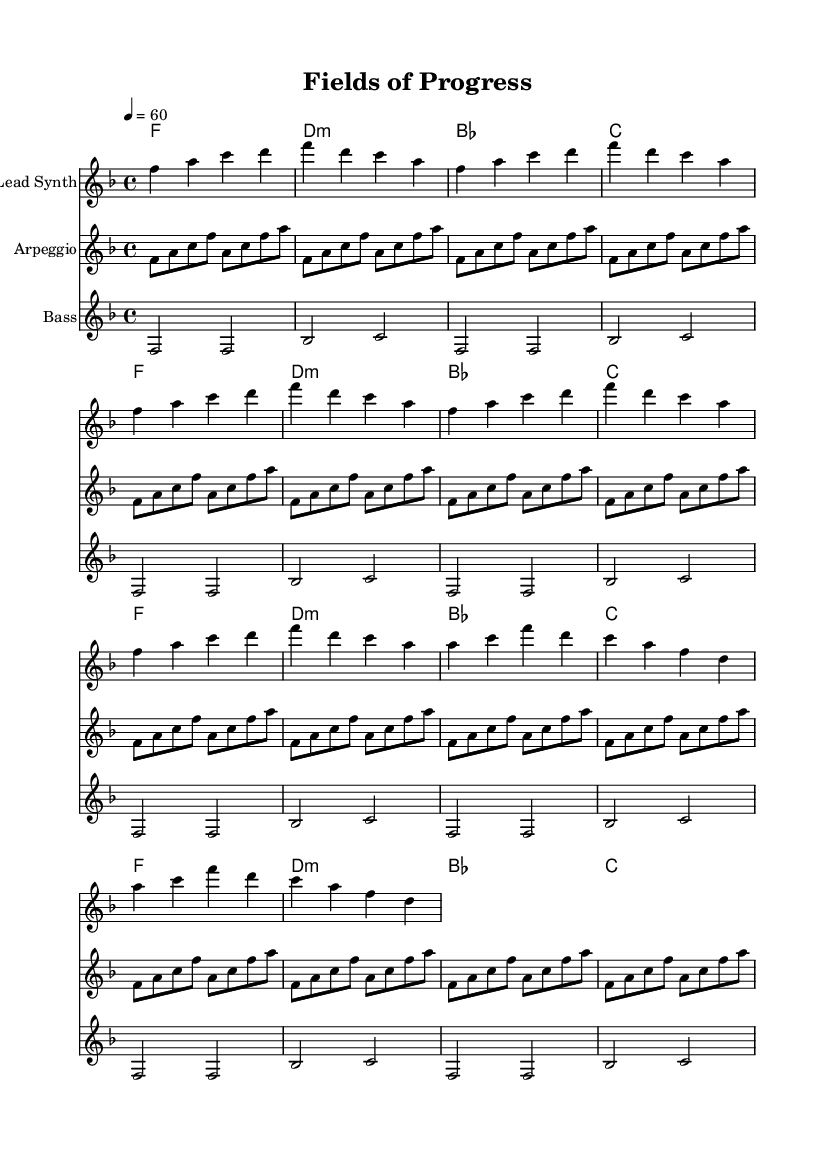What is the key signature of this music? The key signature is F major, which contains one flat note (B flat) in its scale. This can be determined by identifying the key signature symbol at the beginning of the score.
Answer: F major What is the time signature of this music? The time signature displayed at the beginning of the score is 4/4, indicating that there are four beats per measure and the quarter note gets one beat. This is seen in the time signature marking following the clef.
Answer: 4/4 What is the tempo marking for this piece? The tempo marking is a metronome marking shown as "4 = 60", meaning that there are 60 beats per minute, with each beat being represented by a quarter note. This is indicated next to the tempo indication at the start of the score.
Answer: 60 How many measures are there in Theme A? Theme A spans 16 measures, as identified by the notation in the lead synth section that repeats for three additional times after the initial two measures. Each repeat expands the total count to 16.
Answer: 16 Which instrument plays the arpeggio part? The instrument designated for the arpeggio part is labeled as "Arpeggio" in the score, and the part is notated on its own staff below the lead synth, clearly indicating it is a separate instrument line.
Answer: Arpeggio What is the chord progression in the harmonies section? The chord progression in the harmonies section includes F major, D minor, B flat major, and C major, which are repeated over four measures according to the chord mode notation found in that staff.
Answer: F, D:min, B, C How many times is the Lead Synth theme repeated? The Lead Synth theme is repeated three more times after its initial presentation, as indicated by the repeat marking which unfolds three additional cycles of the four-measure theme. The total counts add up to four instances.
Answer: 4 